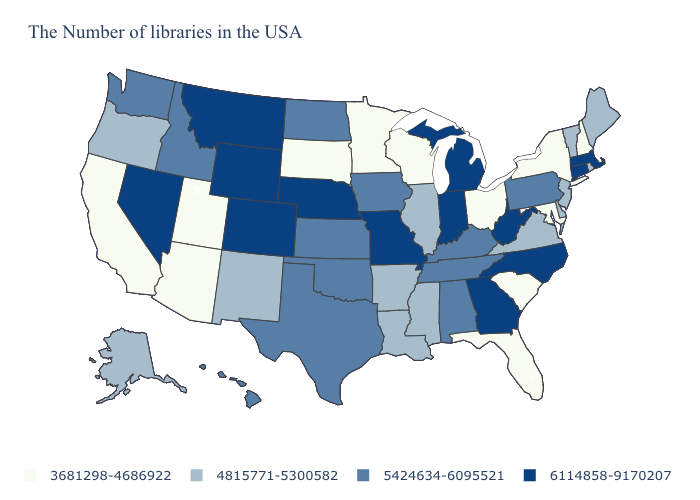Does the map have missing data?
Keep it brief. No. What is the lowest value in the West?
Quick response, please. 3681298-4686922. Name the states that have a value in the range 4815771-5300582?
Concise answer only. Maine, Rhode Island, Vermont, New Jersey, Delaware, Virginia, Illinois, Mississippi, Louisiana, Arkansas, New Mexico, Oregon, Alaska. Does New Hampshire have the lowest value in the USA?
Give a very brief answer. Yes. Does Florida have the lowest value in the USA?
Concise answer only. Yes. Which states hav the highest value in the Northeast?
Be succinct. Massachusetts, Connecticut. Which states have the lowest value in the USA?
Concise answer only. New Hampshire, New York, Maryland, South Carolina, Ohio, Florida, Wisconsin, Minnesota, South Dakota, Utah, Arizona, California. Name the states that have a value in the range 6114858-9170207?
Quick response, please. Massachusetts, Connecticut, North Carolina, West Virginia, Georgia, Michigan, Indiana, Missouri, Nebraska, Wyoming, Colorado, Montana, Nevada. What is the value of North Dakota?
Write a very short answer. 5424634-6095521. Is the legend a continuous bar?
Concise answer only. No. Name the states that have a value in the range 3681298-4686922?
Answer briefly. New Hampshire, New York, Maryland, South Carolina, Ohio, Florida, Wisconsin, Minnesota, South Dakota, Utah, Arizona, California. Name the states that have a value in the range 4815771-5300582?
Answer briefly. Maine, Rhode Island, Vermont, New Jersey, Delaware, Virginia, Illinois, Mississippi, Louisiana, Arkansas, New Mexico, Oregon, Alaska. Which states have the lowest value in the USA?
Write a very short answer. New Hampshire, New York, Maryland, South Carolina, Ohio, Florida, Wisconsin, Minnesota, South Dakota, Utah, Arizona, California. Name the states that have a value in the range 5424634-6095521?
Write a very short answer. Pennsylvania, Kentucky, Alabama, Tennessee, Iowa, Kansas, Oklahoma, Texas, North Dakota, Idaho, Washington, Hawaii. 